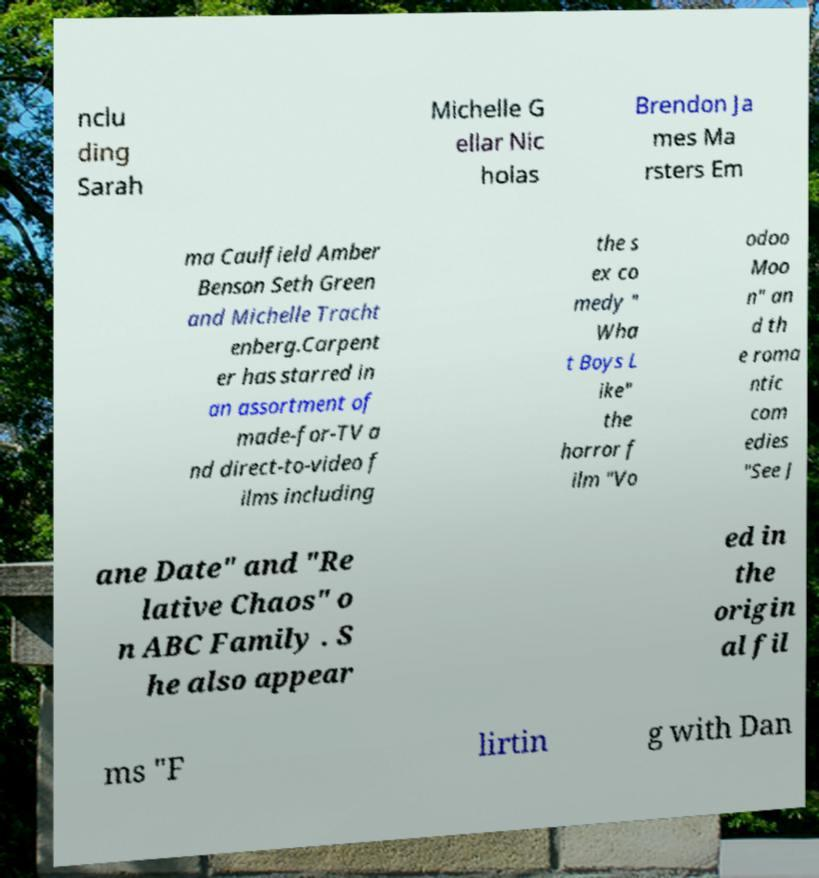Can you read and provide the text displayed in the image?This photo seems to have some interesting text. Can you extract and type it out for me? nclu ding Sarah Michelle G ellar Nic holas Brendon Ja mes Ma rsters Em ma Caulfield Amber Benson Seth Green and Michelle Tracht enberg.Carpent er has starred in an assortment of made-for-TV a nd direct-to-video f ilms including the s ex co medy " Wha t Boys L ike" the horror f ilm "Vo odoo Moo n" an d th e roma ntic com edies "See J ane Date" and "Re lative Chaos" o n ABC Family . S he also appear ed in the origin al fil ms "F lirtin g with Dan 